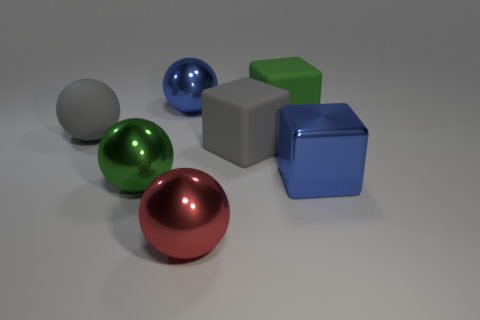What number of cylinders are either big blue things or matte things?
Your answer should be very brief. 0. There is a shiny cube that is the same size as the blue metal sphere; what color is it?
Your answer should be compact. Blue. What number of big blue metallic things are both behind the green matte block and right of the big gray rubber cube?
Ensure brevity in your answer.  0. What is the big gray ball made of?
Provide a short and direct response. Rubber. How many objects are green things or gray matte things?
Ensure brevity in your answer.  4. Does the blue thing to the left of the green cube have the same size as the gray thing on the right side of the large green ball?
Your answer should be compact. Yes. What number of other things are there of the same size as the shiny block?
Provide a succinct answer. 6. How many objects are either large cubes behind the gray sphere or metal objects that are on the left side of the blue block?
Your answer should be very brief. 4. Is the material of the green block the same as the green thing that is left of the red ball?
Make the answer very short. No. What number of other objects are the same shape as the big red metal thing?
Your answer should be compact. 3. 